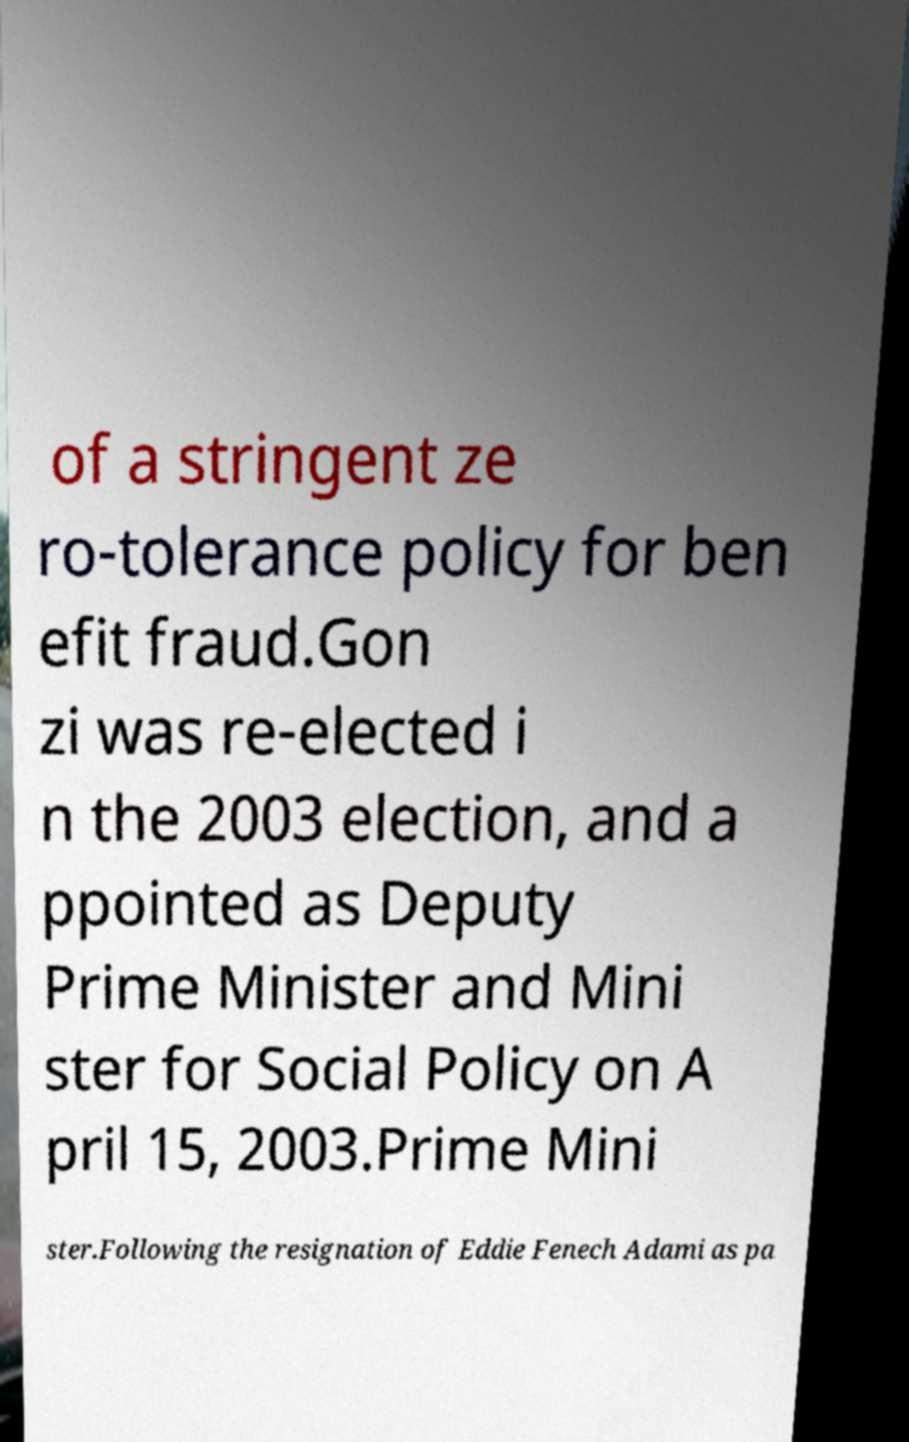Could you assist in decoding the text presented in this image and type it out clearly? of a stringent ze ro-tolerance policy for ben efit fraud.Gon zi was re-elected i n the 2003 election, and a ppointed as Deputy Prime Minister and Mini ster for Social Policy on A pril 15, 2003.Prime Mini ster.Following the resignation of Eddie Fenech Adami as pa 